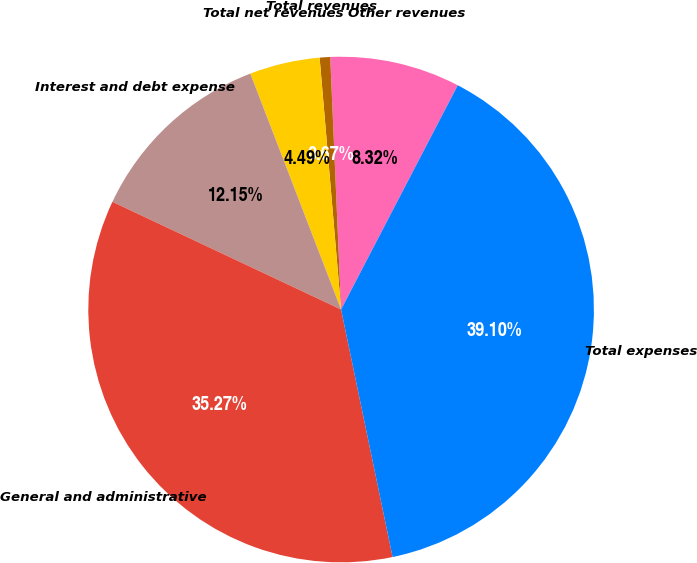Convert chart. <chart><loc_0><loc_0><loc_500><loc_500><pie_chart><fcel>Other revenues<fcel>Total revenues<fcel>Total net revenues<fcel>Interest and debt expense<fcel>General and administrative<fcel>Total expenses<nl><fcel>8.32%<fcel>0.67%<fcel>4.49%<fcel>12.15%<fcel>35.27%<fcel>39.1%<nl></chart> 